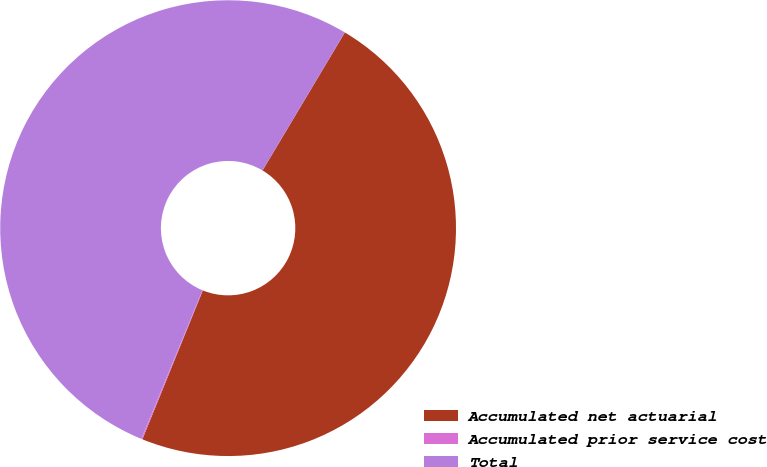Convert chart to OTSL. <chart><loc_0><loc_0><loc_500><loc_500><pie_chart><fcel>Accumulated net actuarial<fcel>Accumulated prior service cost<fcel>Total<nl><fcel>47.58%<fcel>0.08%<fcel>52.34%<nl></chart> 